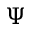Convert formula to latex. <formula><loc_0><loc_0><loc_500><loc_500>\Psi</formula> 